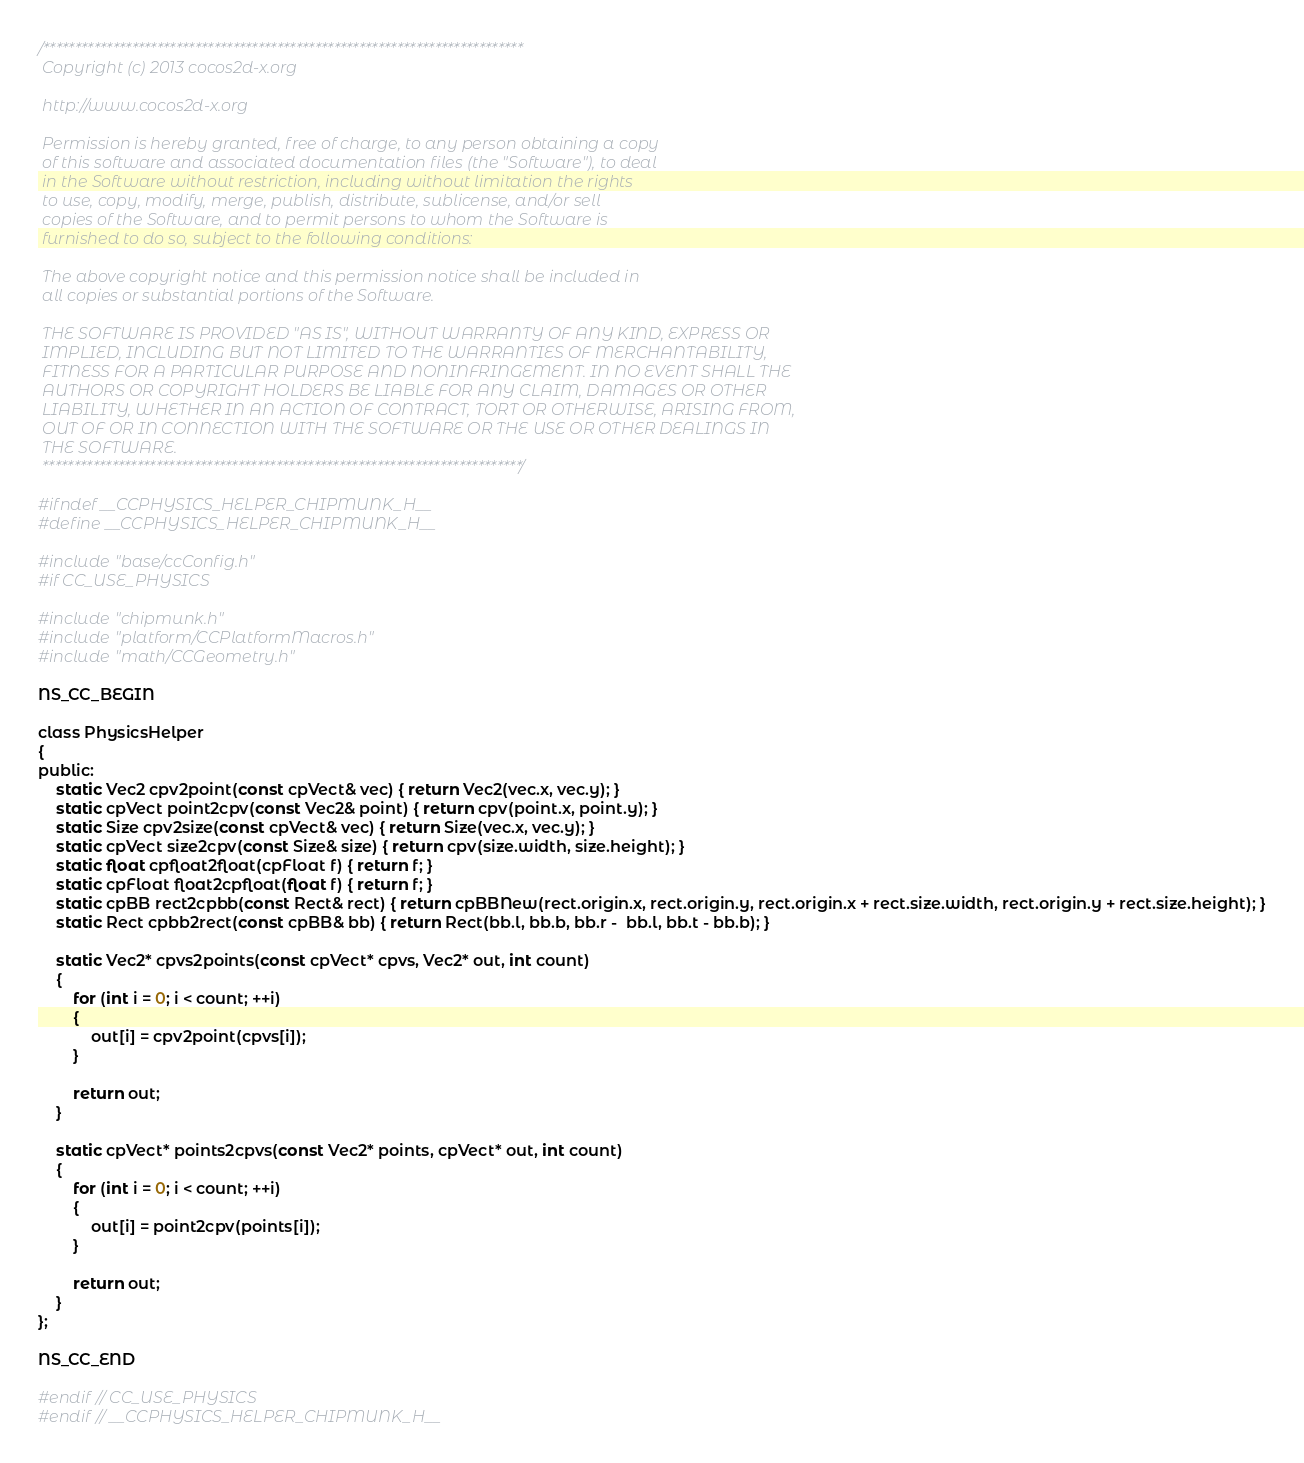Convert code to text. <code><loc_0><loc_0><loc_500><loc_500><_C_>/****************************************************************************
 Copyright (c) 2013 cocos2d-x.org
 
 http://www.cocos2d-x.org
 
 Permission is hereby granted, free of charge, to any person obtaining a copy
 of this software and associated documentation files (the "Software"), to deal
 in the Software without restriction, including without limitation the rights
 to use, copy, modify, merge, publish, distribute, sublicense, and/or sell
 copies of the Software, and to permit persons to whom the Software is
 furnished to do so, subject to the following conditions:
 
 The above copyright notice and this permission notice shall be included in
 all copies or substantial portions of the Software.
 
 THE SOFTWARE IS PROVIDED "AS IS", WITHOUT WARRANTY OF ANY KIND, EXPRESS OR
 IMPLIED, INCLUDING BUT NOT LIMITED TO THE WARRANTIES OF MERCHANTABILITY,
 FITNESS FOR A PARTICULAR PURPOSE AND NONINFRINGEMENT. IN NO EVENT SHALL THE
 AUTHORS OR COPYRIGHT HOLDERS BE LIABLE FOR ANY CLAIM, DAMAGES OR OTHER
 LIABILITY, WHETHER IN AN ACTION OF CONTRACT, TORT OR OTHERWISE, ARISING FROM,
 OUT OF OR IN CONNECTION WITH THE SOFTWARE OR THE USE OR OTHER DEALINGS IN
 THE SOFTWARE.
 ****************************************************************************/

#ifndef __CCPHYSICS_HELPER_CHIPMUNK_H__
#define __CCPHYSICS_HELPER_CHIPMUNK_H__

#include "base/ccConfig.h"
#if CC_USE_PHYSICS

#include "chipmunk.h"
#include "platform/CCPlatformMacros.h"
#include "math/CCGeometry.h"

NS_CC_BEGIN

class PhysicsHelper
{
public:
    static Vec2 cpv2point(const cpVect& vec) { return Vec2(vec.x, vec.y); }
    static cpVect point2cpv(const Vec2& point) { return cpv(point.x, point.y); }
    static Size cpv2size(const cpVect& vec) { return Size(vec.x, vec.y); }
    static cpVect size2cpv(const Size& size) { return cpv(size.width, size.height); }
    static float cpfloat2float(cpFloat f) { return f; }
    static cpFloat float2cpfloat(float f) { return f; }
    static cpBB rect2cpbb(const Rect& rect) { return cpBBNew(rect.origin.x, rect.origin.y, rect.origin.x + rect.size.width, rect.origin.y + rect.size.height); }
    static Rect cpbb2rect(const cpBB& bb) { return Rect(bb.l, bb.b, bb.r -  bb.l, bb.t - bb.b); }
    
    static Vec2* cpvs2points(const cpVect* cpvs, Vec2* out, int count)
    {
        for (int i = 0; i < count; ++i)
        {
            out[i] = cpv2point(cpvs[i]);
        }
        
        return out;
    }
    
    static cpVect* points2cpvs(const Vec2* points, cpVect* out, int count)
    {
        for (int i = 0; i < count; ++i)
        {
            out[i] = point2cpv(points[i]);
        }
        
        return out;
    }
};

NS_CC_END

#endif // CC_USE_PHYSICS
#endif // __CCPHYSICS_HELPER_CHIPMUNK_H__
</code> 